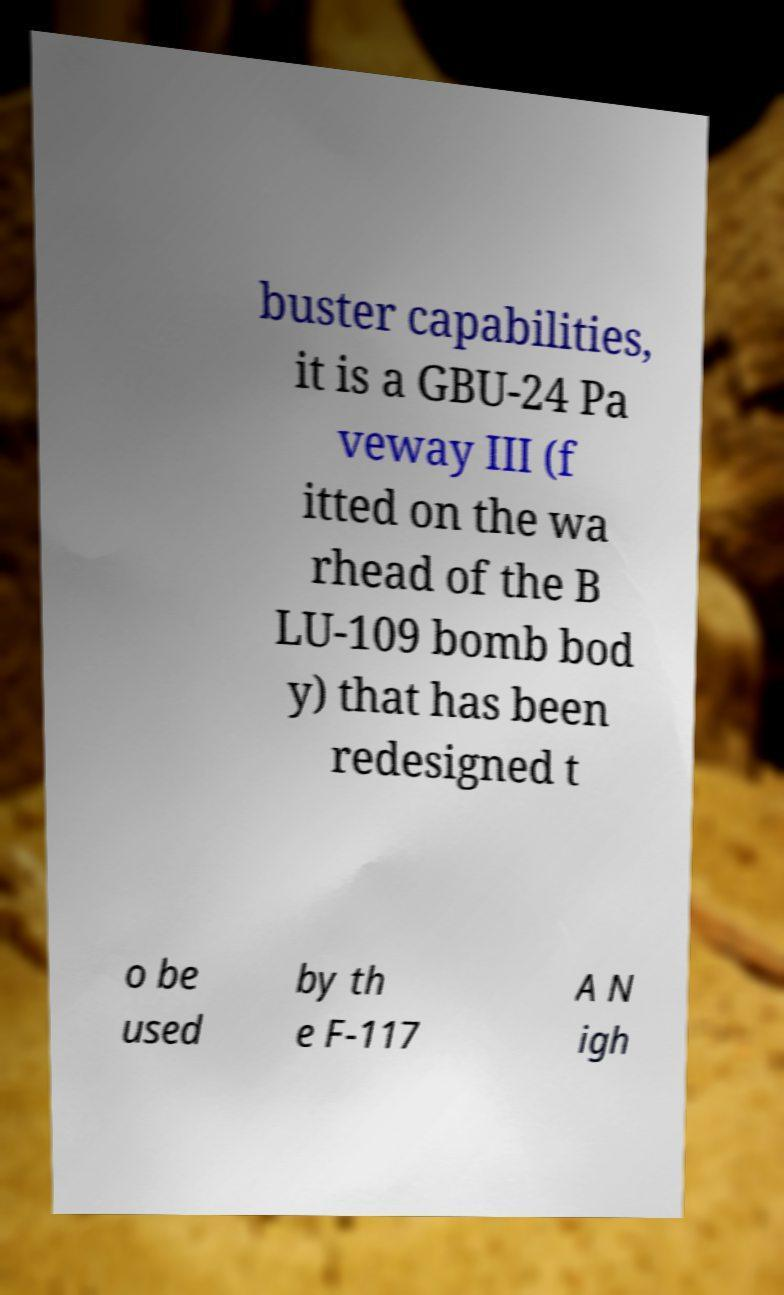Please identify and transcribe the text found in this image. buster capabilities, it is a GBU-24 Pa veway III (f itted on the wa rhead of the B LU-109 bomb bod y) that has been redesigned t o be used by th e F-117 A N igh 